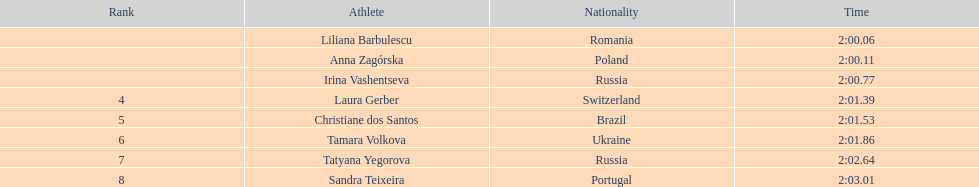In regards to anna zagorska, what was her finishing time? 2:00.11. 